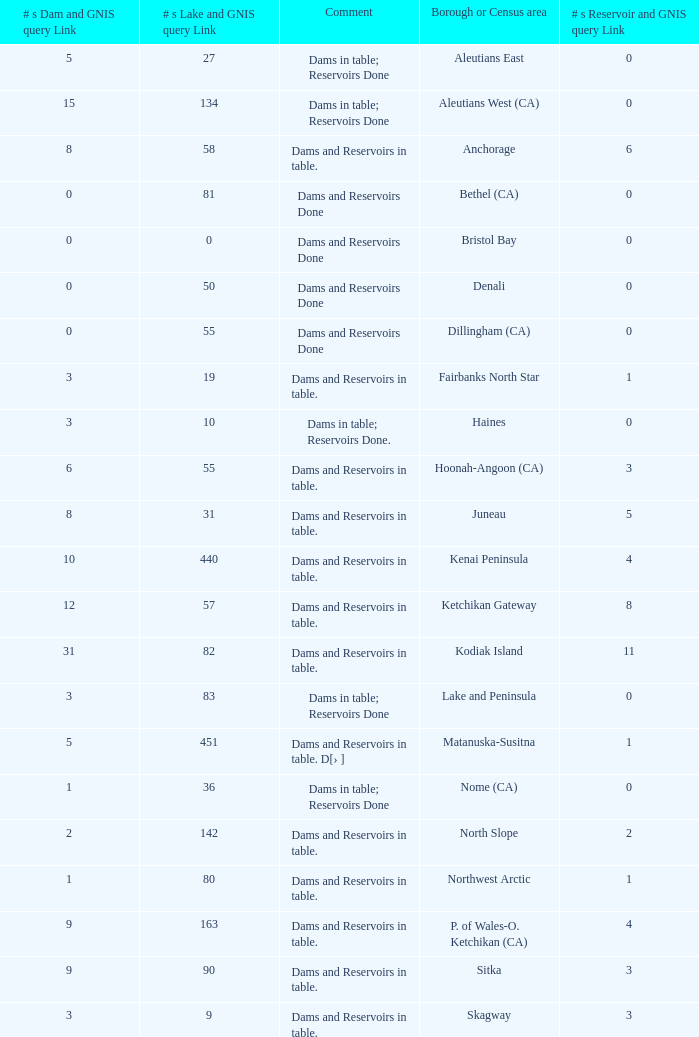Name the most numbers dam and gnis query link for borough or census area for fairbanks north star 3.0. 